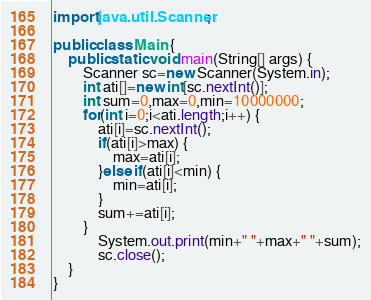<code> <loc_0><loc_0><loc_500><loc_500><_Java_>import java.util.Scanner;

public class Main {
	public static void main(String[] args) {
		Scanner sc=new Scanner(System.in);
		int ati[]=new int[sc.nextInt()];
		int sum=0,max=0,min=10000000;
		for(int i=0;i<ati.length;i++) {
			ati[i]=sc.nextInt();
			if(ati[i]>max) {
				max=ati[i];
			}else if(ati[i]<min) {
				min=ati[i];
			}
			sum+=ati[i];
		}
			System.out.print(min+" "+max+" "+sum);
			sc.close();
	}
}
</code> 